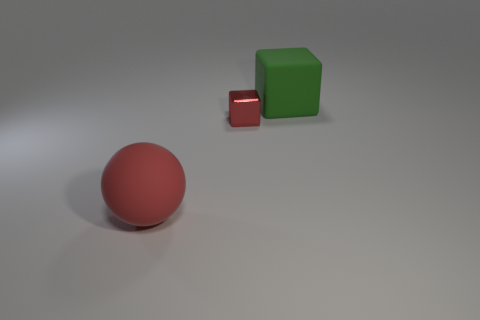Is the color of the large rubber cube the same as the object that is to the left of the tiny red metallic block?
Provide a short and direct response. No. The big object that is the same shape as the tiny object is what color?
Make the answer very short. Green. Do the tiny cube and the red thing in front of the shiny cube have the same material?
Ensure brevity in your answer.  No. What color is the small cube?
Provide a short and direct response. Red. What color is the rubber object that is behind the rubber thing to the left of the rubber thing that is behind the matte sphere?
Your answer should be very brief. Green. Is the shape of the large red rubber object the same as the big object that is right of the red ball?
Ensure brevity in your answer.  No. What color is the object that is right of the matte ball and in front of the green rubber block?
Give a very brief answer. Red. Are there any other metallic things that have the same shape as the tiny red object?
Make the answer very short. No. Does the metallic thing have the same color as the large rubber ball?
Offer a very short reply. Yes. Is there a small red block that is in front of the matte object that is in front of the large block?
Provide a short and direct response. No. 